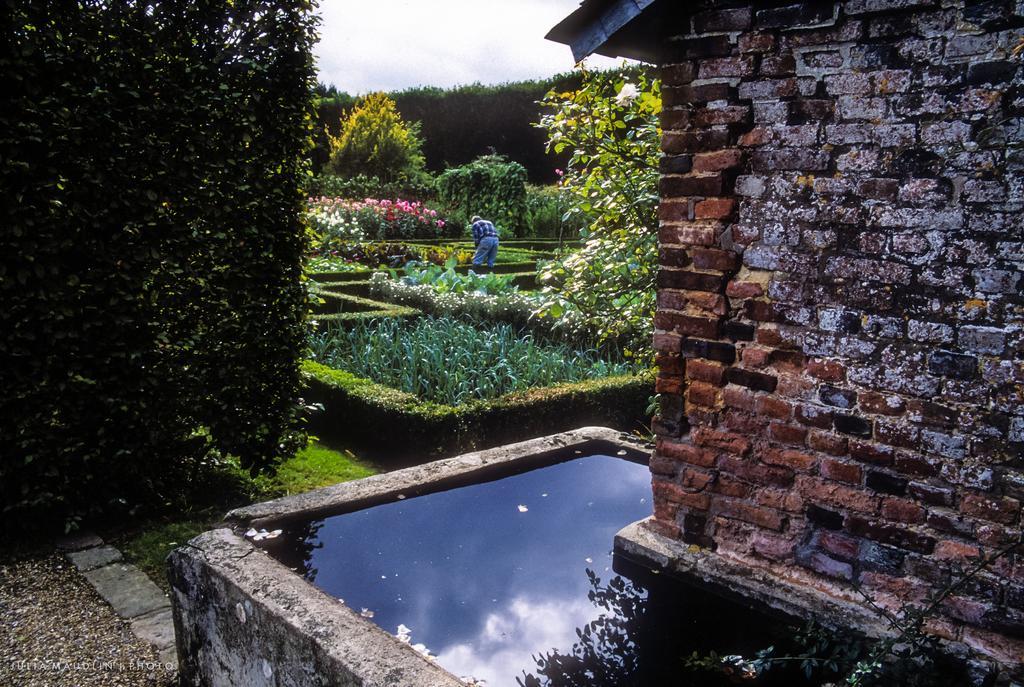In one or two sentences, can you explain what this image depicts? This looks like a garden. Here is the wall, which is built with the bricks. This is a person standing. These are the trees, plants and bushes. I can see the flowers. Here is the water. 